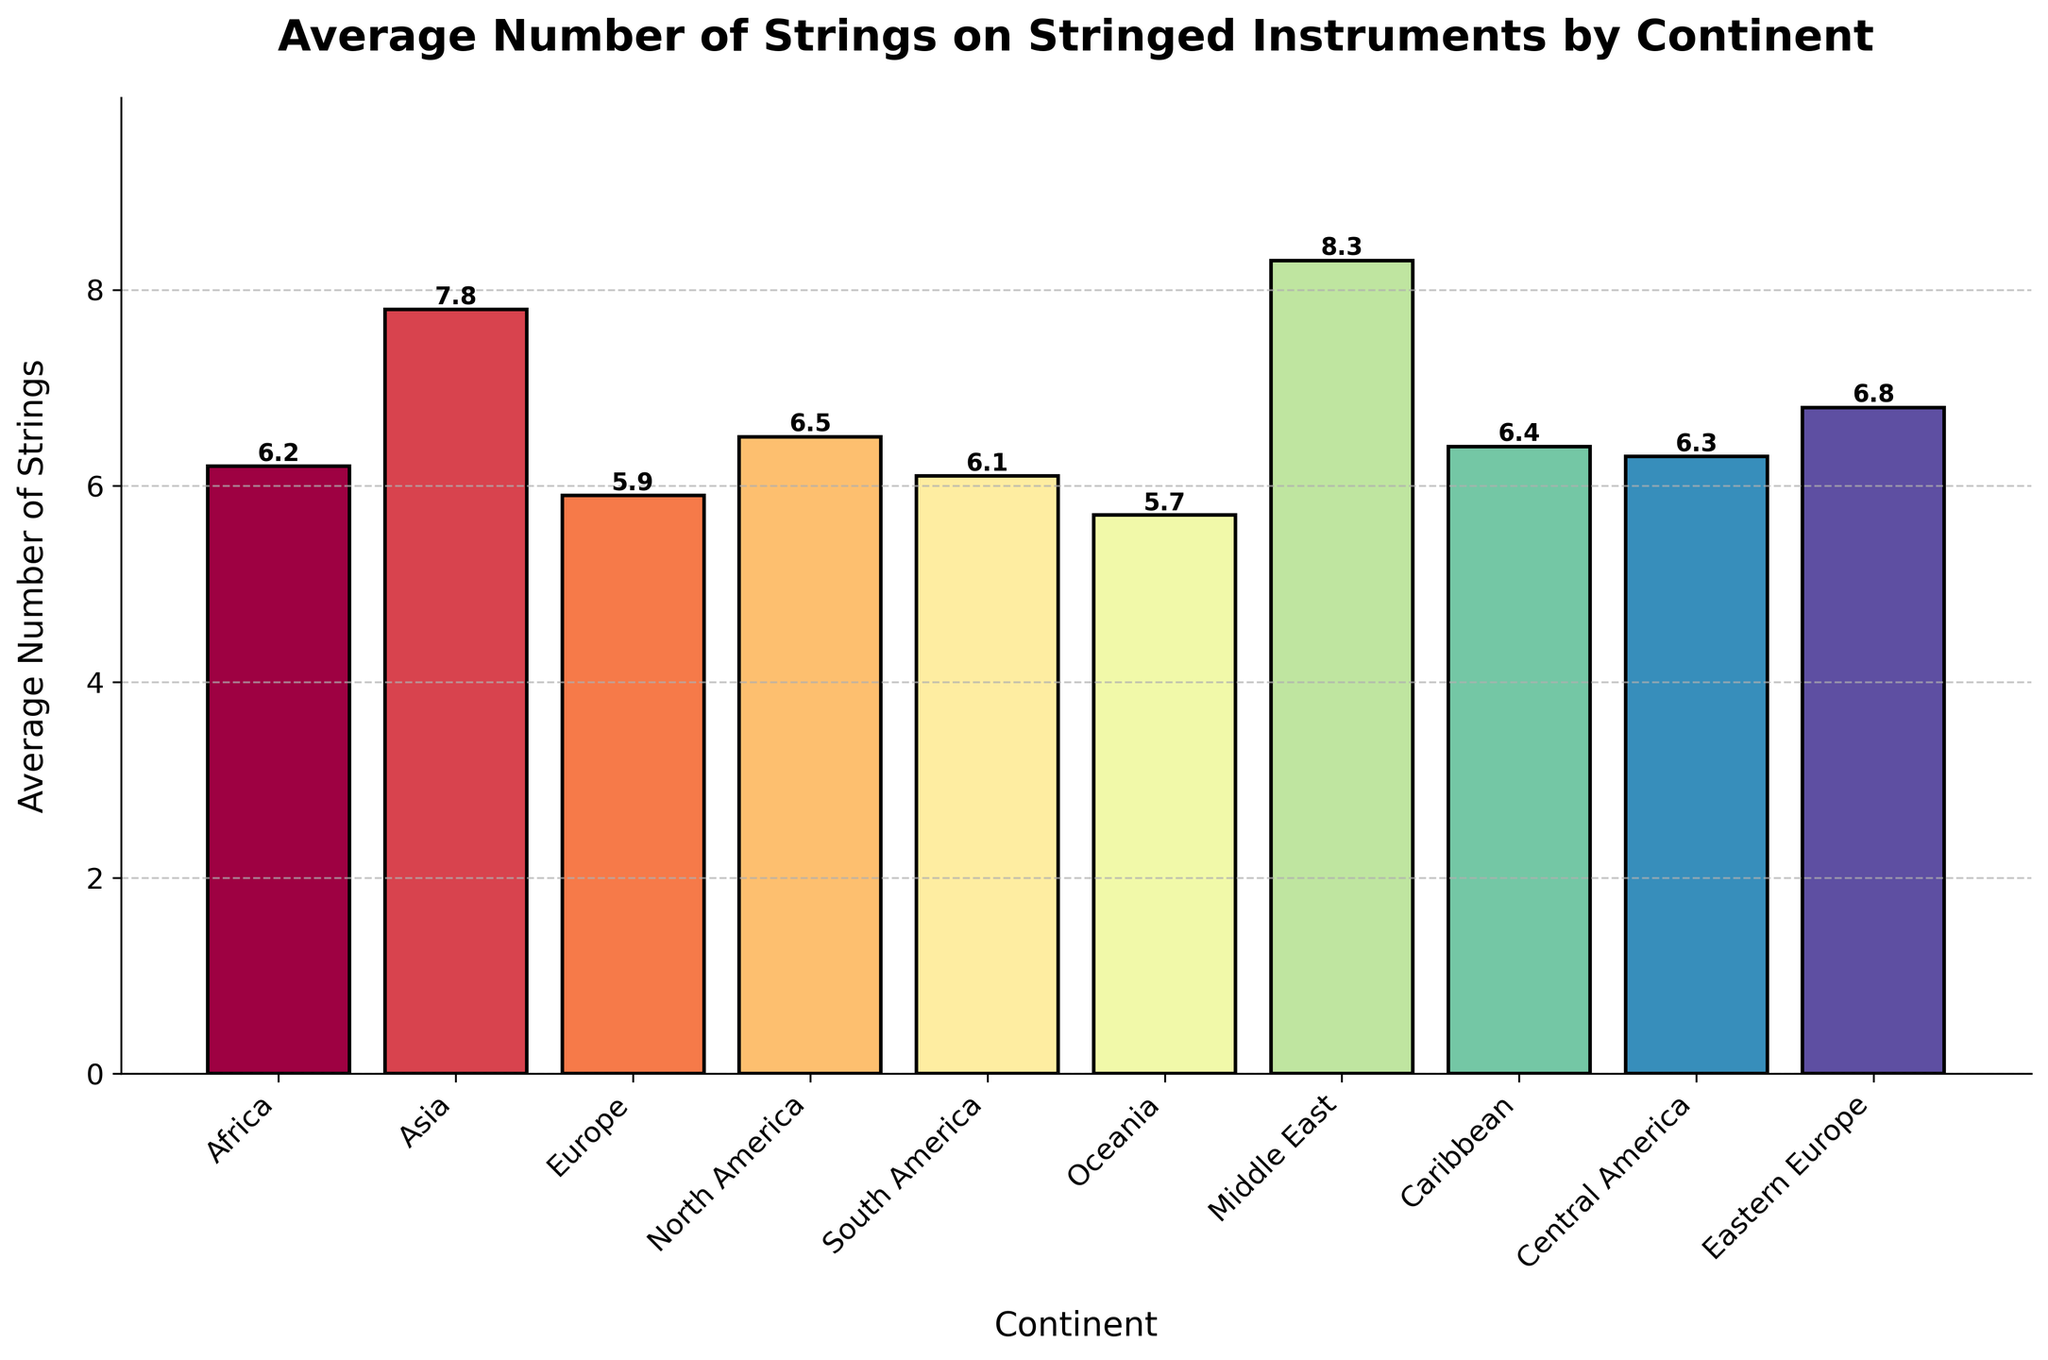What is the continent with the highest average number of strings on stringed instruments? The continent with the highest bar represents the highest average number of strings. From the chart, the Middle East has the highest bar.
Answer: Middle East Which continent has a lower average number of strings, Europe or Oceania? Compare the heights of the bars for Europe and Oceania. Oceania has a bar height of 5.7, which is lower than Europe's 5.9.
Answer: Oceania What is the difference in the average number of strings between Asia and Africa? Subtract the average number of strings in Africa (6.2) from that in Asia (7.8). The difference is 7.8 - 6.2.
Answer: 1.6 Among the continents listed, which ones have an average number of strings greater than 6.5? Identify the continents with bar heights higher than 6.5. They are Asia, Middle East, and Eastern Europe.
Answer: Asia, Middle East, Eastern Europe What is the total average number of strings when you add the values for Europe, North America, and South America? Add the average number of strings for Europe (5.9), North America (6.5), and South America (6.1). The sum is 5.9 + 6.5 + 6.1.
Answer: 18.5 How much higher is the average number of strings in the Middle East compared to the Caribbean? Subtract the average number of strings in the Caribbean (6.4) from the Middle East (8.3). The difference is 8.3 - 6.4.
Answer: 1.9 Which continent has the lowest average number of strings on stringed instruments? The continent with the shortest bar represents the lowest average number of strings. From the chart, Oceania has the shortest bar.
Answer: Oceania What is the average number of strings across all continents listed? Add all the average numbers of strings and then divide by the number of continents (10). (6.2 + 7.8 + 5.9 + 6.5 + 6.1 + 5.7 + 8.3 + 6.4 + 6.3 + 6.8) / 10.
Answer: 6.6 Compare the average number of strings in Eastern Europe to Central America. Which one is higher? Compare the bar heights for Eastern Europe (6.8) and Central America (6.3). Eastern Europe's value is higher.
Answer: Eastern Europe 